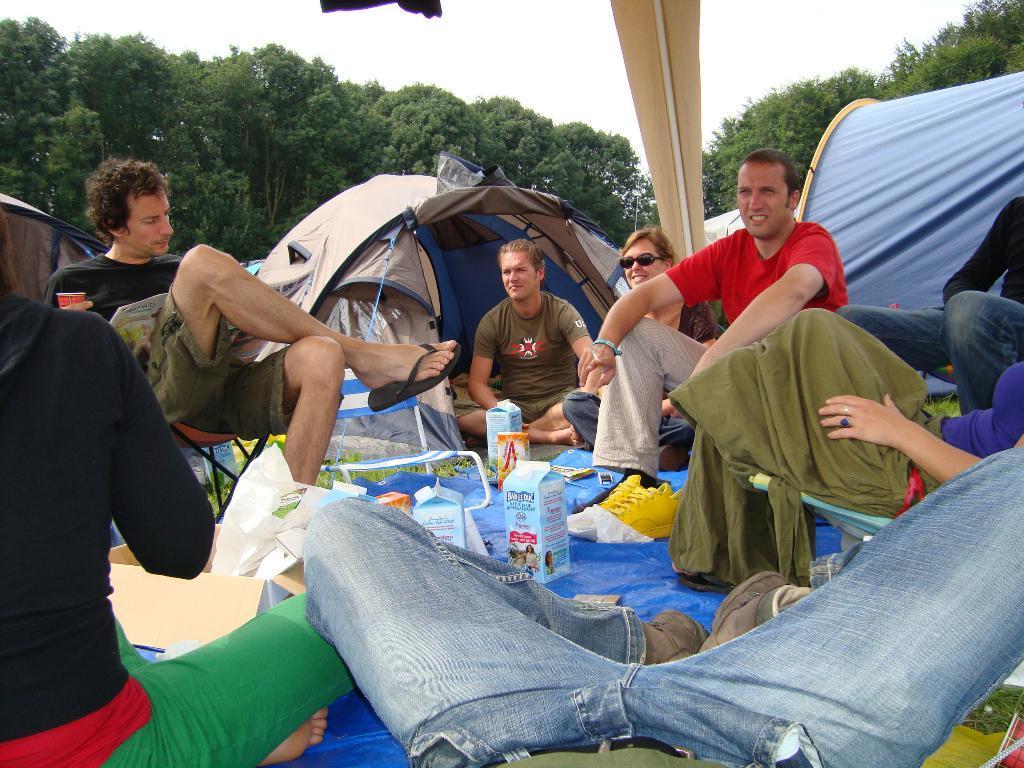How would you summarize this image in a sentence or two? In this image we can see persons sitting on the chairs and on the floor. In addition to this we can see cardboard cartons, polythene covers, tents, trees and sky. 